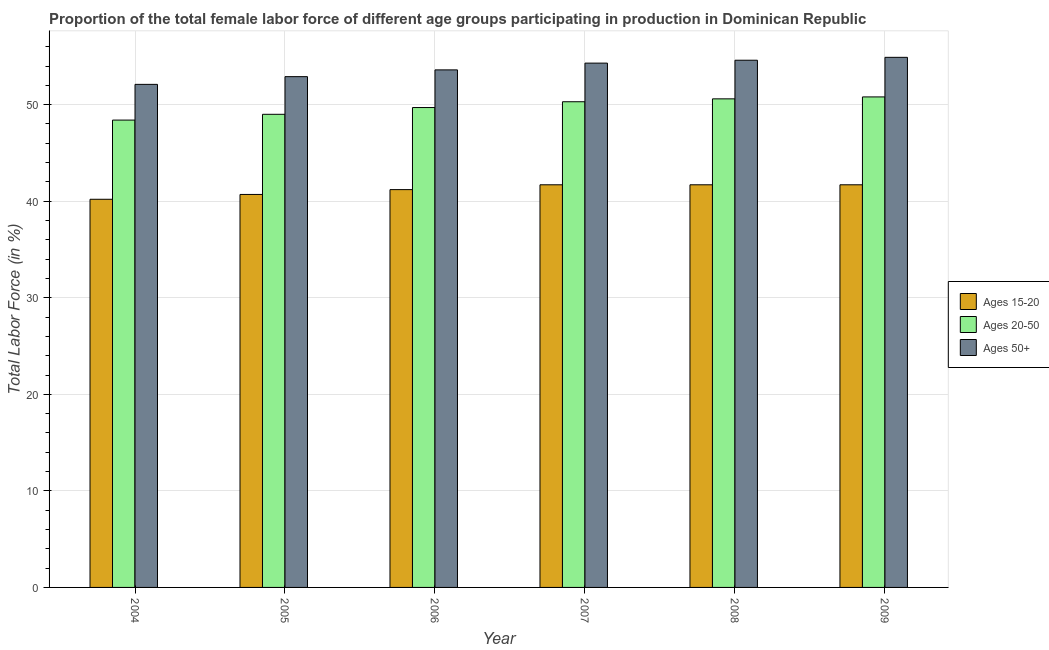How many different coloured bars are there?
Offer a terse response. 3. How many groups of bars are there?
Ensure brevity in your answer.  6. Are the number of bars per tick equal to the number of legend labels?
Offer a very short reply. Yes. How many bars are there on the 5th tick from the right?
Offer a very short reply. 3. What is the label of the 5th group of bars from the left?
Give a very brief answer. 2008. In how many cases, is the number of bars for a given year not equal to the number of legend labels?
Provide a short and direct response. 0. What is the percentage of female labor force within the age group 15-20 in 2005?
Provide a succinct answer. 40.7. Across all years, what is the maximum percentage of female labor force above age 50?
Provide a short and direct response. 54.9. Across all years, what is the minimum percentage of female labor force above age 50?
Provide a short and direct response. 52.1. In which year was the percentage of female labor force within the age group 15-20 minimum?
Offer a terse response. 2004. What is the total percentage of female labor force within the age group 15-20 in the graph?
Ensure brevity in your answer.  247.2. What is the difference between the percentage of female labor force above age 50 in 2007 and the percentage of female labor force within the age group 15-20 in 2005?
Your answer should be very brief. 1.4. What is the average percentage of female labor force within the age group 15-20 per year?
Offer a very short reply. 41.2. What is the ratio of the percentage of female labor force within the age group 15-20 in 2004 to that in 2009?
Your response must be concise. 0.96. Is the difference between the percentage of female labor force within the age group 15-20 in 2004 and 2005 greater than the difference between the percentage of female labor force above age 50 in 2004 and 2005?
Offer a terse response. No. What is the difference between the highest and the second highest percentage of female labor force within the age group 15-20?
Make the answer very short. 0. What is the difference between the highest and the lowest percentage of female labor force within the age group 15-20?
Your answer should be compact. 1.5. In how many years, is the percentage of female labor force within the age group 20-50 greater than the average percentage of female labor force within the age group 20-50 taken over all years?
Give a very brief answer. 3. What does the 2nd bar from the left in 2009 represents?
Offer a very short reply. Ages 20-50. What does the 1st bar from the right in 2004 represents?
Your answer should be compact. Ages 50+. Is it the case that in every year, the sum of the percentage of female labor force within the age group 15-20 and percentage of female labor force within the age group 20-50 is greater than the percentage of female labor force above age 50?
Make the answer very short. Yes. Are all the bars in the graph horizontal?
Make the answer very short. No. Does the graph contain any zero values?
Your response must be concise. No. Does the graph contain grids?
Your answer should be very brief. Yes. How are the legend labels stacked?
Provide a short and direct response. Vertical. What is the title of the graph?
Make the answer very short. Proportion of the total female labor force of different age groups participating in production in Dominican Republic. Does "Renewable sources" appear as one of the legend labels in the graph?
Ensure brevity in your answer.  No. What is the label or title of the X-axis?
Make the answer very short. Year. What is the label or title of the Y-axis?
Your answer should be compact. Total Labor Force (in %). What is the Total Labor Force (in %) in Ages 15-20 in 2004?
Keep it short and to the point. 40.2. What is the Total Labor Force (in %) of Ages 20-50 in 2004?
Your response must be concise. 48.4. What is the Total Labor Force (in %) of Ages 50+ in 2004?
Make the answer very short. 52.1. What is the Total Labor Force (in %) in Ages 15-20 in 2005?
Ensure brevity in your answer.  40.7. What is the Total Labor Force (in %) of Ages 50+ in 2005?
Keep it short and to the point. 52.9. What is the Total Labor Force (in %) in Ages 15-20 in 2006?
Ensure brevity in your answer.  41.2. What is the Total Labor Force (in %) of Ages 20-50 in 2006?
Offer a terse response. 49.7. What is the Total Labor Force (in %) in Ages 50+ in 2006?
Ensure brevity in your answer.  53.6. What is the Total Labor Force (in %) in Ages 15-20 in 2007?
Your response must be concise. 41.7. What is the Total Labor Force (in %) of Ages 20-50 in 2007?
Offer a very short reply. 50.3. What is the Total Labor Force (in %) in Ages 50+ in 2007?
Give a very brief answer. 54.3. What is the Total Labor Force (in %) in Ages 15-20 in 2008?
Make the answer very short. 41.7. What is the Total Labor Force (in %) of Ages 20-50 in 2008?
Offer a very short reply. 50.6. What is the Total Labor Force (in %) of Ages 50+ in 2008?
Keep it short and to the point. 54.6. What is the Total Labor Force (in %) in Ages 15-20 in 2009?
Your response must be concise. 41.7. What is the Total Labor Force (in %) in Ages 20-50 in 2009?
Provide a short and direct response. 50.8. What is the Total Labor Force (in %) in Ages 50+ in 2009?
Offer a terse response. 54.9. Across all years, what is the maximum Total Labor Force (in %) of Ages 15-20?
Your answer should be compact. 41.7. Across all years, what is the maximum Total Labor Force (in %) in Ages 20-50?
Offer a terse response. 50.8. Across all years, what is the maximum Total Labor Force (in %) in Ages 50+?
Offer a terse response. 54.9. Across all years, what is the minimum Total Labor Force (in %) in Ages 15-20?
Your answer should be very brief. 40.2. Across all years, what is the minimum Total Labor Force (in %) of Ages 20-50?
Offer a very short reply. 48.4. Across all years, what is the minimum Total Labor Force (in %) of Ages 50+?
Your answer should be very brief. 52.1. What is the total Total Labor Force (in %) in Ages 15-20 in the graph?
Give a very brief answer. 247.2. What is the total Total Labor Force (in %) in Ages 20-50 in the graph?
Provide a succinct answer. 298.8. What is the total Total Labor Force (in %) of Ages 50+ in the graph?
Provide a short and direct response. 322.4. What is the difference between the Total Labor Force (in %) of Ages 15-20 in 2004 and that in 2005?
Your answer should be compact. -0.5. What is the difference between the Total Labor Force (in %) of Ages 50+ in 2004 and that in 2005?
Offer a very short reply. -0.8. What is the difference between the Total Labor Force (in %) of Ages 20-50 in 2004 and that in 2006?
Provide a short and direct response. -1.3. What is the difference between the Total Labor Force (in %) of Ages 50+ in 2004 and that in 2008?
Ensure brevity in your answer.  -2.5. What is the difference between the Total Labor Force (in %) of Ages 20-50 in 2004 and that in 2009?
Offer a terse response. -2.4. What is the difference between the Total Labor Force (in %) of Ages 50+ in 2004 and that in 2009?
Give a very brief answer. -2.8. What is the difference between the Total Labor Force (in %) in Ages 15-20 in 2005 and that in 2006?
Your answer should be very brief. -0.5. What is the difference between the Total Labor Force (in %) in Ages 50+ in 2005 and that in 2006?
Your answer should be very brief. -0.7. What is the difference between the Total Labor Force (in %) of Ages 15-20 in 2005 and that in 2007?
Your answer should be very brief. -1. What is the difference between the Total Labor Force (in %) of Ages 20-50 in 2005 and that in 2007?
Offer a terse response. -1.3. What is the difference between the Total Labor Force (in %) in Ages 50+ in 2005 and that in 2007?
Ensure brevity in your answer.  -1.4. What is the difference between the Total Labor Force (in %) in Ages 15-20 in 2005 and that in 2009?
Give a very brief answer. -1. What is the difference between the Total Labor Force (in %) of Ages 20-50 in 2005 and that in 2009?
Keep it short and to the point. -1.8. What is the difference between the Total Labor Force (in %) in Ages 50+ in 2005 and that in 2009?
Your answer should be compact. -2. What is the difference between the Total Labor Force (in %) of Ages 50+ in 2006 and that in 2007?
Give a very brief answer. -0.7. What is the difference between the Total Labor Force (in %) in Ages 15-20 in 2006 and that in 2008?
Give a very brief answer. -0.5. What is the difference between the Total Labor Force (in %) of Ages 15-20 in 2006 and that in 2009?
Your answer should be very brief. -0.5. What is the difference between the Total Labor Force (in %) of Ages 20-50 in 2006 and that in 2009?
Offer a very short reply. -1.1. What is the difference between the Total Labor Force (in %) of Ages 15-20 in 2007 and that in 2008?
Give a very brief answer. 0. What is the difference between the Total Labor Force (in %) of Ages 20-50 in 2007 and that in 2009?
Keep it short and to the point. -0.5. What is the difference between the Total Labor Force (in %) of Ages 50+ in 2007 and that in 2009?
Your answer should be very brief. -0.6. What is the difference between the Total Labor Force (in %) in Ages 15-20 in 2008 and that in 2009?
Your answer should be very brief. 0. What is the difference between the Total Labor Force (in %) in Ages 20-50 in 2008 and that in 2009?
Your answer should be very brief. -0.2. What is the difference between the Total Labor Force (in %) of Ages 20-50 in 2004 and the Total Labor Force (in %) of Ages 50+ in 2006?
Provide a succinct answer. -5.2. What is the difference between the Total Labor Force (in %) in Ages 15-20 in 2004 and the Total Labor Force (in %) in Ages 50+ in 2007?
Give a very brief answer. -14.1. What is the difference between the Total Labor Force (in %) in Ages 20-50 in 2004 and the Total Labor Force (in %) in Ages 50+ in 2007?
Provide a succinct answer. -5.9. What is the difference between the Total Labor Force (in %) in Ages 15-20 in 2004 and the Total Labor Force (in %) in Ages 20-50 in 2008?
Give a very brief answer. -10.4. What is the difference between the Total Labor Force (in %) in Ages 15-20 in 2004 and the Total Labor Force (in %) in Ages 50+ in 2008?
Give a very brief answer. -14.4. What is the difference between the Total Labor Force (in %) in Ages 15-20 in 2004 and the Total Labor Force (in %) in Ages 50+ in 2009?
Offer a terse response. -14.7. What is the difference between the Total Labor Force (in %) of Ages 20-50 in 2005 and the Total Labor Force (in %) of Ages 50+ in 2006?
Provide a short and direct response. -4.6. What is the difference between the Total Labor Force (in %) of Ages 15-20 in 2005 and the Total Labor Force (in %) of Ages 20-50 in 2007?
Give a very brief answer. -9.6. What is the difference between the Total Labor Force (in %) of Ages 15-20 in 2005 and the Total Labor Force (in %) of Ages 50+ in 2007?
Your response must be concise. -13.6. What is the difference between the Total Labor Force (in %) in Ages 15-20 in 2005 and the Total Labor Force (in %) in Ages 20-50 in 2008?
Give a very brief answer. -9.9. What is the difference between the Total Labor Force (in %) in Ages 15-20 in 2005 and the Total Labor Force (in %) in Ages 50+ in 2008?
Offer a terse response. -13.9. What is the difference between the Total Labor Force (in %) of Ages 15-20 in 2006 and the Total Labor Force (in %) of Ages 50+ in 2007?
Keep it short and to the point. -13.1. What is the difference between the Total Labor Force (in %) in Ages 20-50 in 2006 and the Total Labor Force (in %) in Ages 50+ in 2007?
Provide a short and direct response. -4.6. What is the difference between the Total Labor Force (in %) in Ages 15-20 in 2006 and the Total Labor Force (in %) in Ages 20-50 in 2008?
Offer a very short reply. -9.4. What is the difference between the Total Labor Force (in %) of Ages 15-20 in 2006 and the Total Labor Force (in %) of Ages 50+ in 2008?
Provide a succinct answer. -13.4. What is the difference between the Total Labor Force (in %) of Ages 20-50 in 2006 and the Total Labor Force (in %) of Ages 50+ in 2008?
Your answer should be very brief. -4.9. What is the difference between the Total Labor Force (in %) of Ages 15-20 in 2006 and the Total Labor Force (in %) of Ages 20-50 in 2009?
Provide a succinct answer. -9.6. What is the difference between the Total Labor Force (in %) in Ages 15-20 in 2006 and the Total Labor Force (in %) in Ages 50+ in 2009?
Your answer should be very brief. -13.7. What is the difference between the Total Labor Force (in %) in Ages 15-20 in 2007 and the Total Labor Force (in %) in Ages 20-50 in 2008?
Offer a terse response. -8.9. What is the difference between the Total Labor Force (in %) of Ages 15-20 in 2007 and the Total Labor Force (in %) of Ages 20-50 in 2009?
Your answer should be compact. -9.1. What is the difference between the Total Labor Force (in %) in Ages 15-20 in 2007 and the Total Labor Force (in %) in Ages 50+ in 2009?
Offer a terse response. -13.2. What is the difference between the Total Labor Force (in %) in Ages 20-50 in 2007 and the Total Labor Force (in %) in Ages 50+ in 2009?
Your response must be concise. -4.6. What is the difference between the Total Labor Force (in %) in Ages 15-20 in 2008 and the Total Labor Force (in %) in Ages 20-50 in 2009?
Your answer should be compact. -9.1. What is the difference between the Total Labor Force (in %) in Ages 15-20 in 2008 and the Total Labor Force (in %) in Ages 50+ in 2009?
Your answer should be very brief. -13.2. What is the average Total Labor Force (in %) of Ages 15-20 per year?
Offer a terse response. 41.2. What is the average Total Labor Force (in %) of Ages 20-50 per year?
Ensure brevity in your answer.  49.8. What is the average Total Labor Force (in %) of Ages 50+ per year?
Offer a terse response. 53.73. In the year 2004, what is the difference between the Total Labor Force (in %) of Ages 15-20 and Total Labor Force (in %) of Ages 20-50?
Make the answer very short. -8.2. In the year 2005, what is the difference between the Total Labor Force (in %) of Ages 15-20 and Total Labor Force (in %) of Ages 20-50?
Provide a succinct answer. -8.3. In the year 2005, what is the difference between the Total Labor Force (in %) of Ages 20-50 and Total Labor Force (in %) of Ages 50+?
Provide a short and direct response. -3.9. In the year 2007, what is the difference between the Total Labor Force (in %) of Ages 15-20 and Total Labor Force (in %) of Ages 20-50?
Your answer should be very brief. -8.6. In the year 2007, what is the difference between the Total Labor Force (in %) in Ages 15-20 and Total Labor Force (in %) in Ages 50+?
Your response must be concise. -12.6. In the year 2007, what is the difference between the Total Labor Force (in %) in Ages 20-50 and Total Labor Force (in %) in Ages 50+?
Provide a succinct answer. -4. In the year 2008, what is the difference between the Total Labor Force (in %) of Ages 15-20 and Total Labor Force (in %) of Ages 50+?
Your answer should be compact. -12.9. In the year 2008, what is the difference between the Total Labor Force (in %) in Ages 20-50 and Total Labor Force (in %) in Ages 50+?
Provide a succinct answer. -4. In the year 2009, what is the difference between the Total Labor Force (in %) of Ages 15-20 and Total Labor Force (in %) of Ages 20-50?
Provide a short and direct response. -9.1. In the year 2009, what is the difference between the Total Labor Force (in %) in Ages 15-20 and Total Labor Force (in %) in Ages 50+?
Ensure brevity in your answer.  -13.2. What is the ratio of the Total Labor Force (in %) of Ages 15-20 in 2004 to that in 2005?
Give a very brief answer. 0.99. What is the ratio of the Total Labor Force (in %) in Ages 20-50 in 2004 to that in 2005?
Your answer should be very brief. 0.99. What is the ratio of the Total Labor Force (in %) of Ages 50+ in 2004 to that in 2005?
Make the answer very short. 0.98. What is the ratio of the Total Labor Force (in %) of Ages 15-20 in 2004 to that in 2006?
Your answer should be very brief. 0.98. What is the ratio of the Total Labor Force (in %) of Ages 20-50 in 2004 to that in 2006?
Make the answer very short. 0.97. What is the ratio of the Total Labor Force (in %) of Ages 50+ in 2004 to that in 2006?
Provide a short and direct response. 0.97. What is the ratio of the Total Labor Force (in %) in Ages 15-20 in 2004 to that in 2007?
Give a very brief answer. 0.96. What is the ratio of the Total Labor Force (in %) in Ages 20-50 in 2004 to that in 2007?
Your answer should be very brief. 0.96. What is the ratio of the Total Labor Force (in %) in Ages 50+ in 2004 to that in 2007?
Offer a terse response. 0.96. What is the ratio of the Total Labor Force (in %) of Ages 15-20 in 2004 to that in 2008?
Give a very brief answer. 0.96. What is the ratio of the Total Labor Force (in %) in Ages 20-50 in 2004 to that in 2008?
Keep it short and to the point. 0.96. What is the ratio of the Total Labor Force (in %) in Ages 50+ in 2004 to that in 2008?
Provide a succinct answer. 0.95. What is the ratio of the Total Labor Force (in %) of Ages 15-20 in 2004 to that in 2009?
Your answer should be compact. 0.96. What is the ratio of the Total Labor Force (in %) of Ages 20-50 in 2004 to that in 2009?
Provide a short and direct response. 0.95. What is the ratio of the Total Labor Force (in %) in Ages 50+ in 2004 to that in 2009?
Your answer should be very brief. 0.95. What is the ratio of the Total Labor Force (in %) in Ages 15-20 in 2005 to that in 2006?
Give a very brief answer. 0.99. What is the ratio of the Total Labor Force (in %) of Ages 20-50 in 2005 to that in 2006?
Keep it short and to the point. 0.99. What is the ratio of the Total Labor Force (in %) of Ages 50+ in 2005 to that in 2006?
Your answer should be very brief. 0.99. What is the ratio of the Total Labor Force (in %) in Ages 20-50 in 2005 to that in 2007?
Ensure brevity in your answer.  0.97. What is the ratio of the Total Labor Force (in %) of Ages 50+ in 2005 to that in 2007?
Your answer should be compact. 0.97. What is the ratio of the Total Labor Force (in %) of Ages 15-20 in 2005 to that in 2008?
Your response must be concise. 0.98. What is the ratio of the Total Labor Force (in %) in Ages 20-50 in 2005 to that in 2008?
Provide a succinct answer. 0.97. What is the ratio of the Total Labor Force (in %) of Ages 50+ in 2005 to that in 2008?
Provide a succinct answer. 0.97. What is the ratio of the Total Labor Force (in %) of Ages 15-20 in 2005 to that in 2009?
Offer a very short reply. 0.98. What is the ratio of the Total Labor Force (in %) of Ages 20-50 in 2005 to that in 2009?
Offer a very short reply. 0.96. What is the ratio of the Total Labor Force (in %) of Ages 50+ in 2005 to that in 2009?
Provide a succinct answer. 0.96. What is the ratio of the Total Labor Force (in %) in Ages 15-20 in 2006 to that in 2007?
Your answer should be very brief. 0.99. What is the ratio of the Total Labor Force (in %) in Ages 20-50 in 2006 to that in 2007?
Your answer should be compact. 0.99. What is the ratio of the Total Labor Force (in %) in Ages 50+ in 2006 to that in 2007?
Provide a succinct answer. 0.99. What is the ratio of the Total Labor Force (in %) in Ages 15-20 in 2006 to that in 2008?
Ensure brevity in your answer.  0.99. What is the ratio of the Total Labor Force (in %) of Ages 20-50 in 2006 to that in 2008?
Provide a short and direct response. 0.98. What is the ratio of the Total Labor Force (in %) of Ages 50+ in 2006 to that in 2008?
Provide a short and direct response. 0.98. What is the ratio of the Total Labor Force (in %) of Ages 15-20 in 2006 to that in 2009?
Keep it short and to the point. 0.99. What is the ratio of the Total Labor Force (in %) in Ages 20-50 in 2006 to that in 2009?
Offer a terse response. 0.98. What is the ratio of the Total Labor Force (in %) of Ages 50+ in 2006 to that in 2009?
Offer a terse response. 0.98. What is the ratio of the Total Labor Force (in %) in Ages 15-20 in 2007 to that in 2008?
Your answer should be compact. 1. What is the ratio of the Total Labor Force (in %) of Ages 20-50 in 2007 to that in 2008?
Your answer should be compact. 0.99. What is the ratio of the Total Labor Force (in %) of Ages 50+ in 2007 to that in 2008?
Your answer should be very brief. 0.99. What is the ratio of the Total Labor Force (in %) in Ages 15-20 in 2007 to that in 2009?
Provide a short and direct response. 1. What is the ratio of the Total Labor Force (in %) of Ages 20-50 in 2007 to that in 2009?
Provide a succinct answer. 0.99. What is the ratio of the Total Labor Force (in %) of Ages 50+ in 2007 to that in 2009?
Provide a succinct answer. 0.99. What is the ratio of the Total Labor Force (in %) in Ages 50+ in 2008 to that in 2009?
Ensure brevity in your answer.  0.99. What is the difference between the highest and the second highest Total Labor Force (in %) in Ages 20-50?
Your answer should be compact. 0.2. What is the difference between the highest and the lowest Total Labor Force (in %) of Ages 15-20?
Offer a terse response. 1.5. 